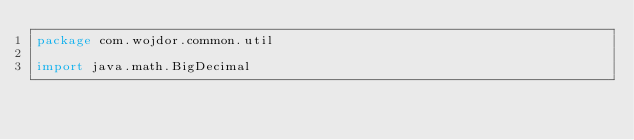<code> <loc_0><loc_0><loc_500><loc_500><_Kotlin_>package com.wojdor.common.util

import java.math.BigDecimal</code> 